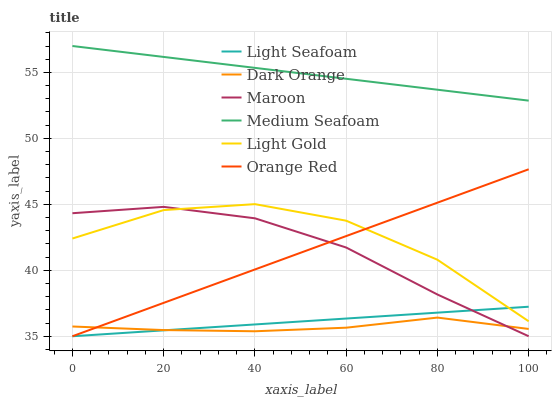Does Dark Orange have the minimum area under the curve?
Answer yes or no. Yes. Does Medium Seafoam have the maximum area under the curve?
Answer yes or no. Yes. Does Maroon have the minimum area under the curve?
Answer yes or no. No. Does Maroon have the maximum area under the curve?
Answer yes or no. No. Is Light Seafoam the smoothest?
Answer yes or no. Yes. Is Light Gold the roughest?
Answer yes or no. Yes. Is Maroon the smoothest?
Answer yes or no. No. Is Maroon the roughest?
Answer yes or no. No. Does Maroon have the lowest value?
Answer yes or no. Yes. Does Light Gold have the lowest value?
Answer yes or no. No. Does Medium Seafoam have the highest value?
Answer yes or no. Yes. Does Maroon have the highest value?
Answer yes or no. No. Is Dark Orange less than Medium Seafoam?
Answer yes or no. Yes. Is Medium Seafoam greater than Light Seafoam?
Answer yes or no. Yes. Does Dark Orange intersect Maroon?
Answer yes or no. Yes. Is Dark Orange less than Maroon?
Answer yes or no. No. Is Dark Orange greater than Maroon?
Answer yes or no. No. Does Dark Orange intersect Medium Seafoam?
Answer yes or no. No. 